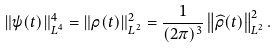Convert formula to latex. <formula><loc_0><loc_0><loc_500><loc_500>\| \psi ( t ) \| _ { L ^ { 4 } } ^ { 4 } = \| \rho ( t ) \| _ { L ^ { 2 } } ^ { 2 } = \frac { 1 } { ( 2 \pi ) ^ { 3 } } \left \| \widehat { \rho } ( t ) \right \| _ { L ^ { 2 } } ^ { 2 } .</formula> 